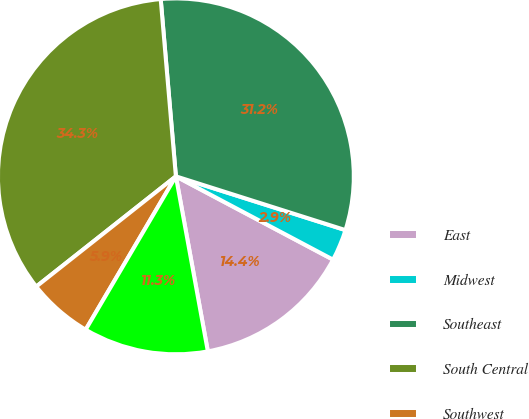Convert chart to OTSL. <chart><loc_0><loc_0><loc_500><loc_500><pie_chart><fcel>East<fcel>Midwest<fcel>Southeast<fcel>South Central<fcel>Southwest<fcel>West<nl><fcel>14.37%<fcel>2.87%<fcel>31.25%<fcel>34.28%<fcel>5.9%<fcel>11.34%<nl></chart> 